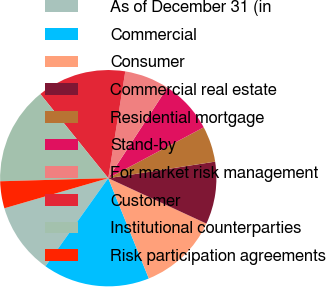Convert chart to OTSL. <chart><loc_0><loc_0><loc_500><loc_500><pie_chart><fcel>As of December 31 (in<fcel>Commercial<fcel>Consumer<fcel>Commercial real estate<fcel>Residential mortgage<fcel>Stand-by<fcel>For market risk management<fcel>Customer<fcel>Institutional counterparties<fcel>Risk participation agreements<nl><fcel>10.66%<fcel>15.97%<fcel>11.99%<fcel>9.34%<fcel>5.35%<fcel>8.01%<fcel>6.68%<fcel>13.32%<fcel>14.65%<fcel>4.03%<nl></chart> 